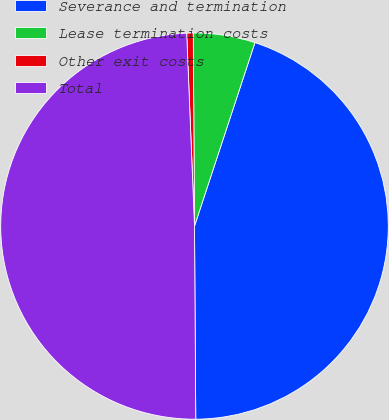<chart> <loc_0><loc_0><loc_500><loc_500><pie_chart><fcel>Severance and termination<fcel>Lease termination costs<fcel>Other exit costs<fcel>Total<nl><fcel>44.85%<fcel>5.15%<fcel>0.54%<fcel>49.46%<nl></chart> 